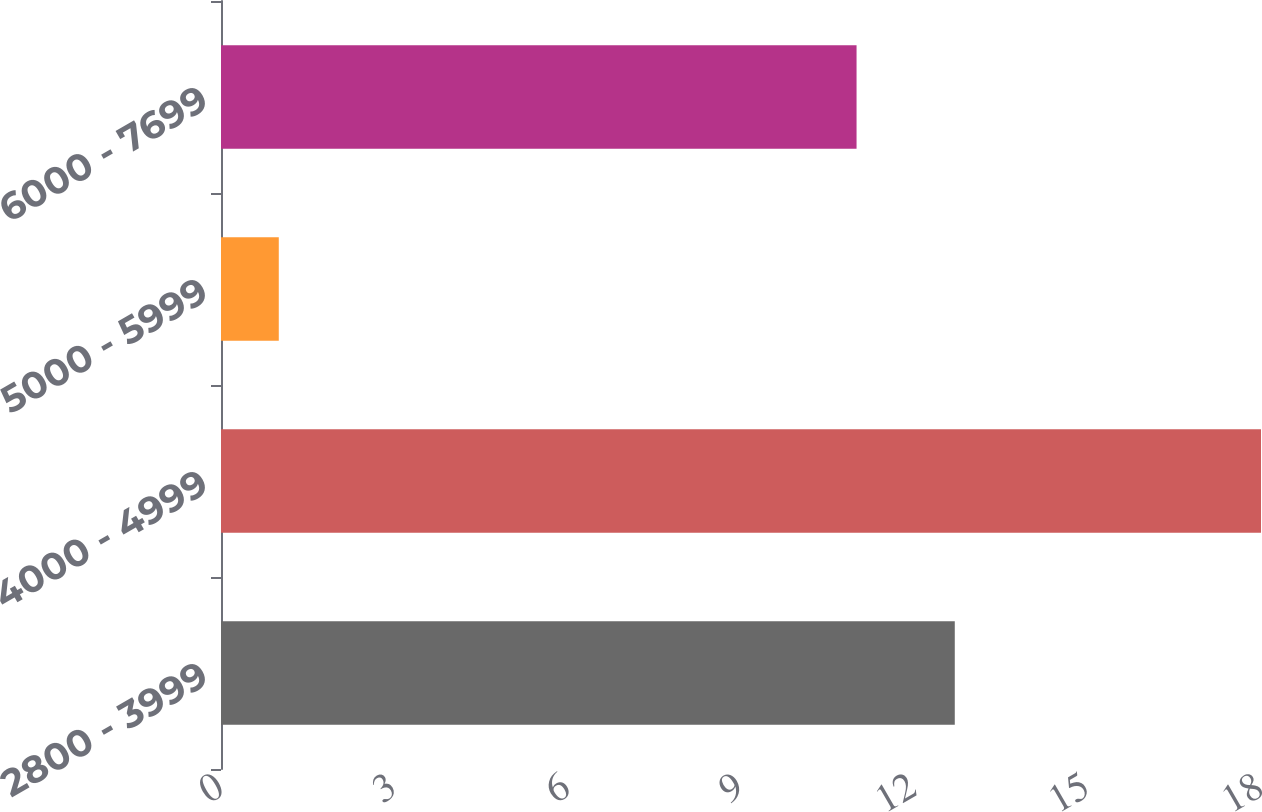Convert chart. <chart><loc_0><loc_0><loc_500><loc_500><bar_chart><fcel>2800 - 3999<fcel>4000 - 4999<fcel>5000 - 5999<fcel>6000 - 7699<nl><fcel>12.7<fcel>18<fcel>1<fcel>11<nl></chart> 